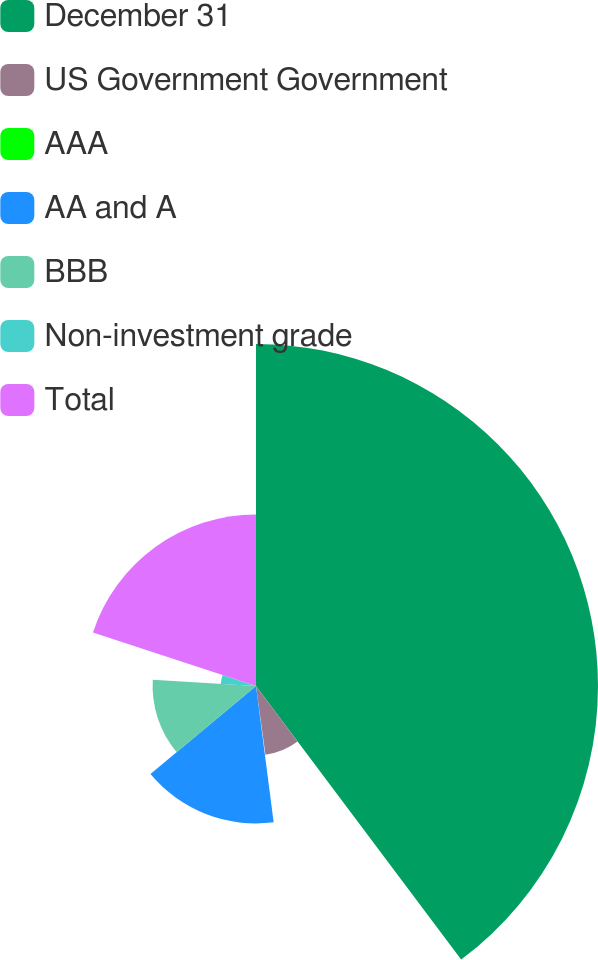Convert chart to OTSL. <chart><loc_0><loc_0><loc_500><loc_500><pie_chart><fcel>December 31<fcel>US Government Government<fcel>AAA<fcel>AA and A<fcel>BBB<fcel>Non-investment grade<fcel>Total<nl><fcel>39.76%<fcel>8.06%<fcel>0.13%<fcel>15.98%<fcel>12.02%<fcel>4.1%<fcel>19.95%<nl></chart> 